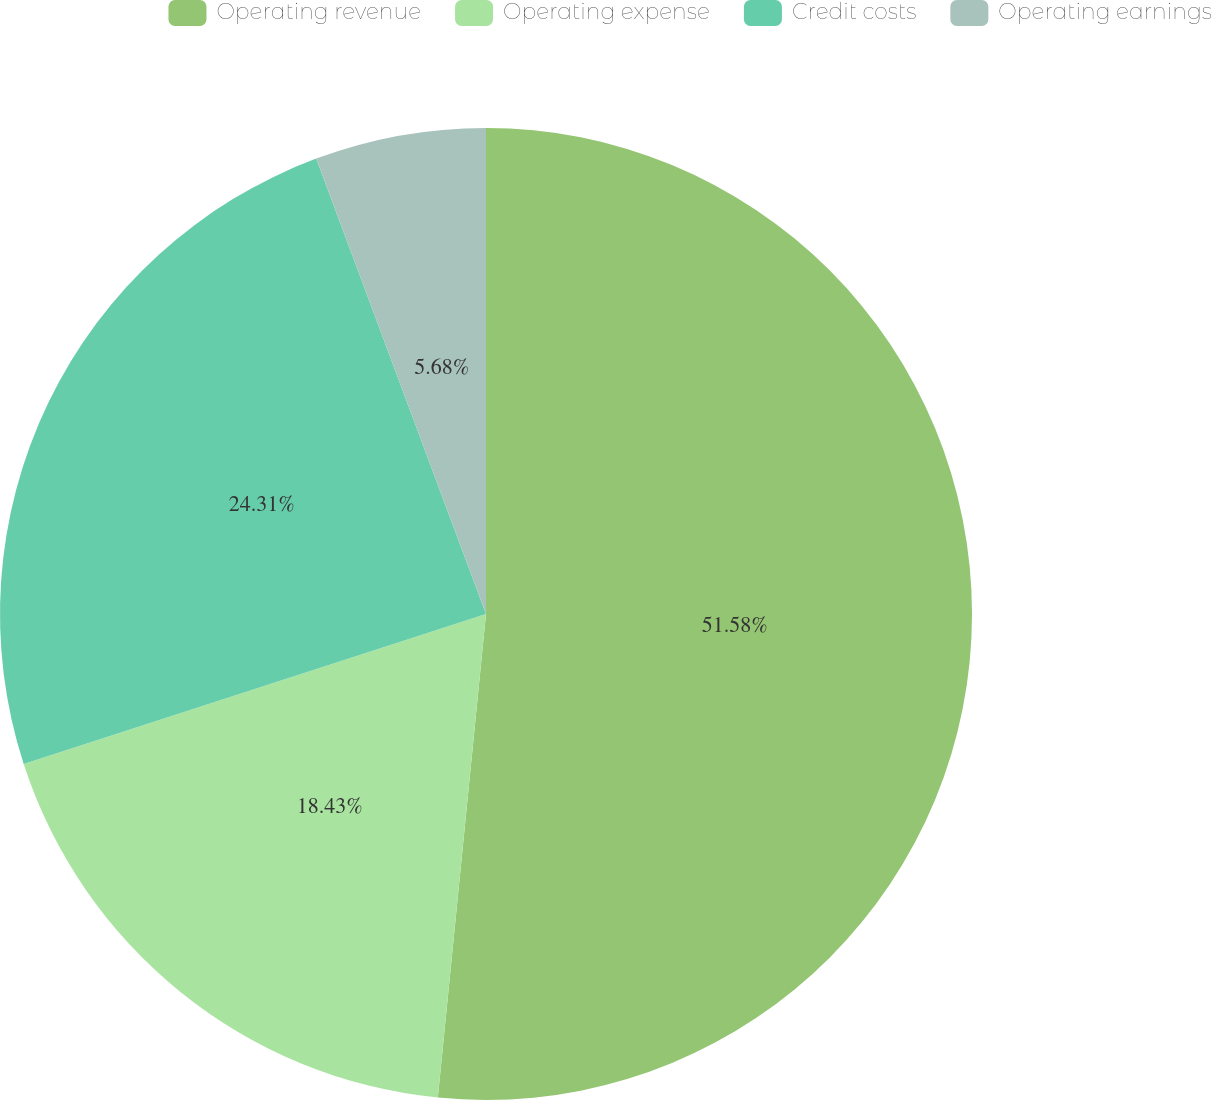Convert chart. <chart><loc_0><loc_0><loc_500><loc_500><pie_chart><fcel>Operating revenue<fcel>Operating expense<fcel>Credit costs<fcel>Operating earnings<nl><fcel>51.58%<fcel>18.43%<fcel>24.31%<fcel>5.68%<nl></chart> 